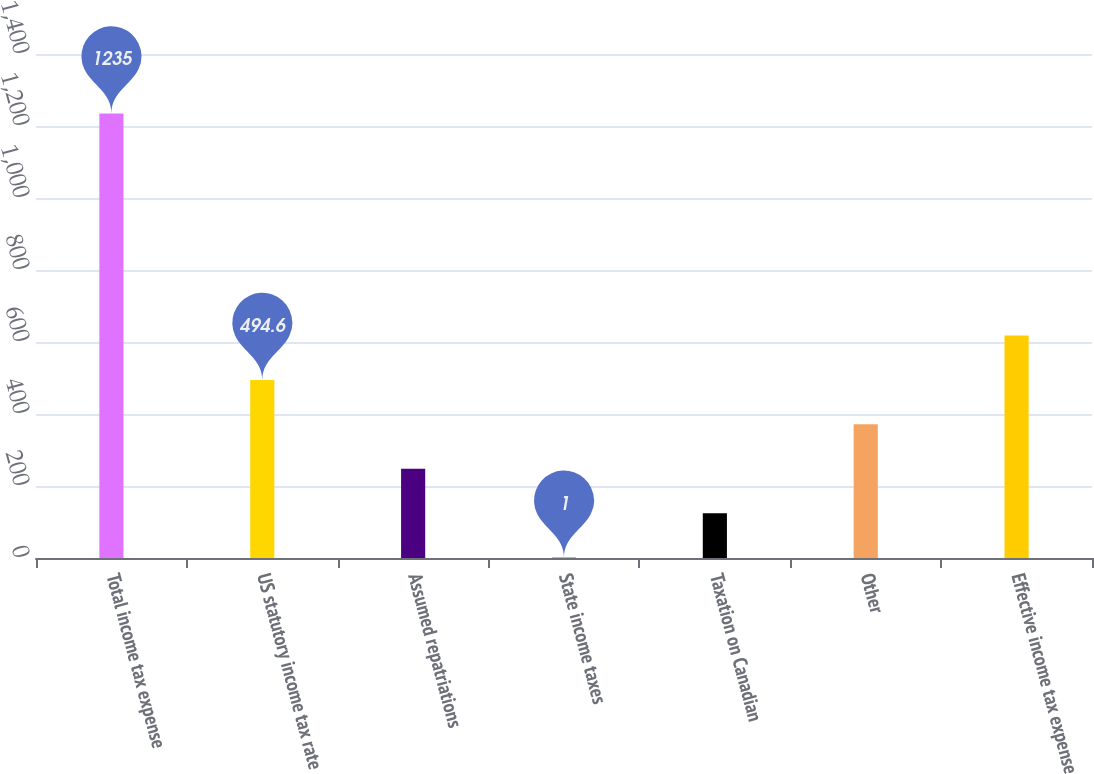Convert chart. <chart><loc_0><loc_0><loc_500><loc_500><bar_chart><fcel>Total income tax expense<fcel>US statutory income tax rate<fcel>Assumed repatriations<fcel>State income taxes<fcel>Taxation on Canadian<fcel>Other<fcel>Effective income tax expense<nl><fcel>1235<fcel>494.6<fcel>247.8<fcel>1<fcel>124.4<fcel>371.2<fcel>618<nl></chart> 